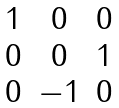Convert formula to latex. <formula><loc_0><loc_0><loc_500><loc_500>\begin{matrix} 1 & 0 & 0 \\ 0 & 0 & 1 \\ 0 & - 1 & 0 \end{matrix}</formula> 